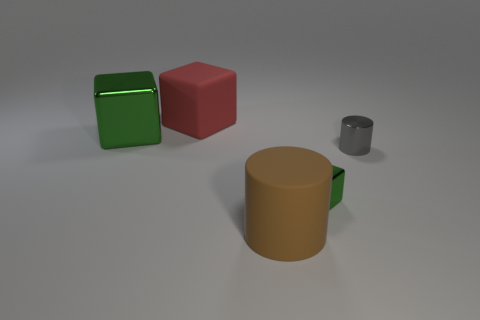Is the number of big rubber cubes greater than the number of large metallic balls?
Your answer should be very brief. Yes. How many other objects are there of the same color as the tiny shiny block?
Give a very brief answer. 1. What number of objects are either large cyan objects or large matte blocks?
Your response must be concise. 1. There is a big thing in front of the gray shiny cylinder; does it have the same shape as the big red matte object?
Your response must be concise. No. There is a big matte object in front of the big matte object behind the small green cube; what color is it?
Your answer should be compact. Brown. Is the number of green objects less than the number of large purple shiny cylinders?
Provide a short and direct response. No. Is there a large green thing that has the same material as the big brown object?
Your response must be concise. No. Is the shape of the red thing the same as the green object that is left of the big brown object?
Make the answer very short. Yes. There is a big green thing; are there any red cubes to the right of it?
Keep it short and to the point. Yes. How many large matte objects are the same shape as the tiny green shiny thing?
Your response must be concise. 1. 